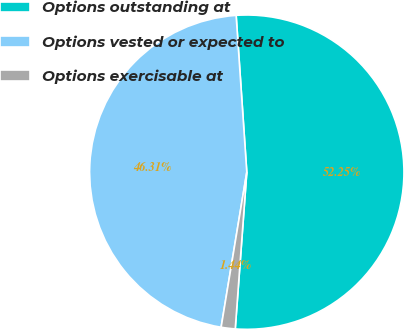<chart> <loc_0><loc_0><loc_500><loc_500><pie_chart><fcel>Options outstanding at<fcel>Options vested or expected to<fcel>Options exercisable at<nl><fcel>52.25%<fcel>46.31%<fcel>1.44%<nl></chart> 